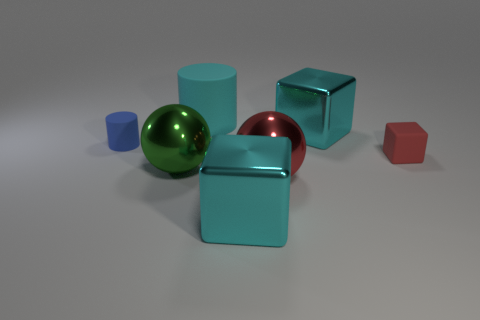Are there more rubber cubes in front of the large green metal sphere than big red balls?
Offer a very short reply. No. There is a metal object that is the same color as the rubber cube; what is its size?
Provide a succinct answer. Large. Are there any cyan things that have the same shape as the red rubber object?
Your answer should be compact. Yes. How many things are tiny blue rubber things or tiny brown metal things?
Keep it short and to the point. 1. How many large cyan metal cubes are in front of the small object on the left side of the shiny cube that is behind the green shiny sphere?
Keep it short and to the point. 1. There is another big thing that is the same shape as the large red object; what is its material?
Ensure brevity in your answer.  Metal. There is a cyan object that is to the right of the big cyan cylinder and behind the green shiny sphere; what material is it?
Give a very brief answer. Metal. Is the number of large objects behind the big matte cylinder less than the number of large matte cylinders in front of the large green metal object?
Make the answer very short. No. How many other objects are there of the same size as the green metal sphere?
Offer a terse response. 4. The large cyan metal object in front of the red thing in front of the red object right of the big red metal ball is what shape?
Make the answer very short. Cube. 